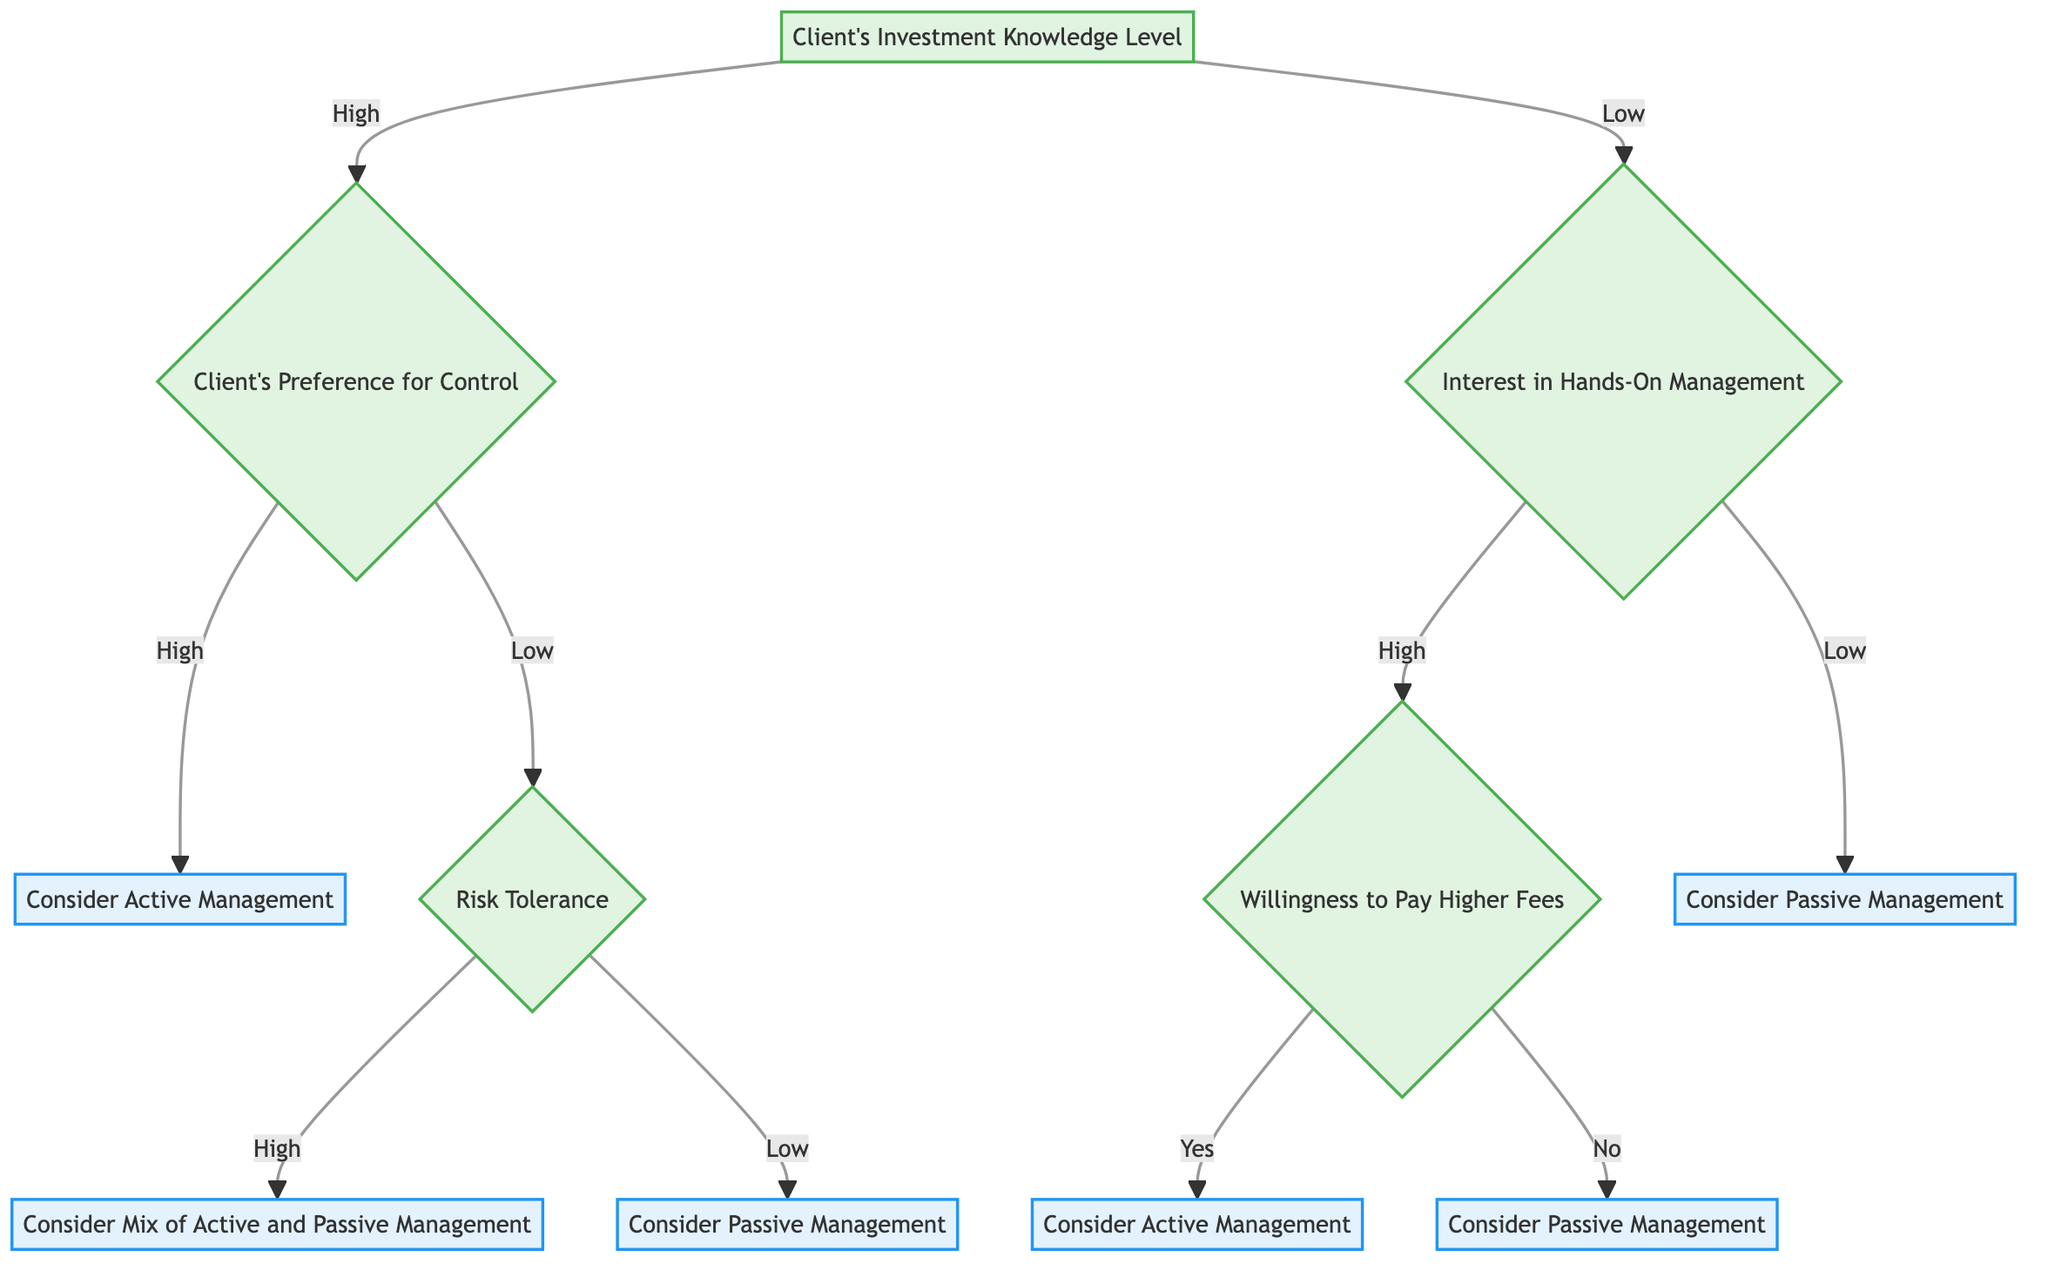What is the initial question in the decision tree? The initial question in the decision tree is "Client's Investment Knowledge Level." It serves as the starting point for the decision-making process, directing the flow of the tree.
Answer: Client's Investment Knowledge Level How many branches are there from the high investment knowledge level? When the investment knowledge level is high, there is one branch that leads to the preference for control, which further divides into more branches, totaling two main outcomes directly linked to this branch.
Answer: Two What does the low preference for control lead to? The low preference for control under high investment knowledge leads to a question about "Risk Tolerance." This is a critical decision point that further splits into potential investment strategies based on the client's risk tolerance level.
Answer: Risk Tolerance If a client is low in investment knowledge and shows a high interest in hands-on management, what decision could lead them to passive management? If a client has low investment knowledge and is interested in hands-on management but indicates "No" to "Willingness to Pay Higher Fees," they would be guided towards considering passive management as the outcome.
Answer: Consider Passive Management What is the final outcome if a client has high investment knowledge, low preference for control, and low risk tolerance? The final outcome in this scenario would be "Consider Passive Management." The pathway takes the client through the necessary decision points, ultimately leading to this recommendation based on their conditions.
Answer: Consider Passive Management What happens when a client has low knowledge and low interest in hands-on management? A client with low investment knowledge and low interest in hands-on management would directly be guided to "Consider Passive Management," indicating a low engagement strategy for their investment portfolio.
Answer: Consider Passive Management What does a “Yes” answer in willingness to pay higher fees lead to? A "Yes" answer regarding willingness to pay higher fees under low investment knowledge and high interest in hands-on management leads to the outcome "Consider Active Management," suggesting a preference for a more involved approach despite potential costs.
Answer: Consider Active Management What number of outcomes exist from the decision tree? The decision tree leads to five distinct outcomes based on the various combinations of client responses, which are mapped through the decision-making paths in the diagram.
Answer: Five 